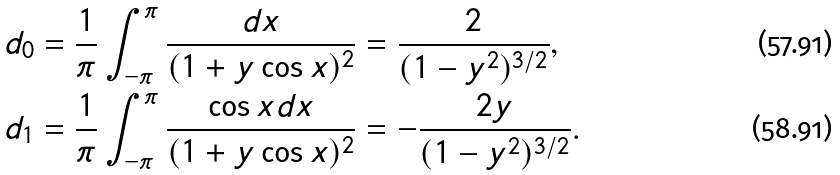Convert formula to latex. <formula><loc_0><loc_0><loc_500><loc_500>d _ { 0 } & = \frac { 1 } { \pi } \int _ { - \pi } ^ { \pi } \frac { d x } { ( 1 + y \cos x ) ^ { 2 } } = \frac { 2 } { ( 1 - y ^ { 2 } ) ^ { 3 / 2 } } , \\ d _ { 1 } & = \frac { 1 } { \pi } \int _ { - \pi } ^ { \pi } \frac { \cos x d x } { ( 1 + y \cos x ) ^ { 2 } } = - \frac { 2 y } { ( 1 - y ^ { 2 } ) ^ { 3 / 2 } } .</formula> 